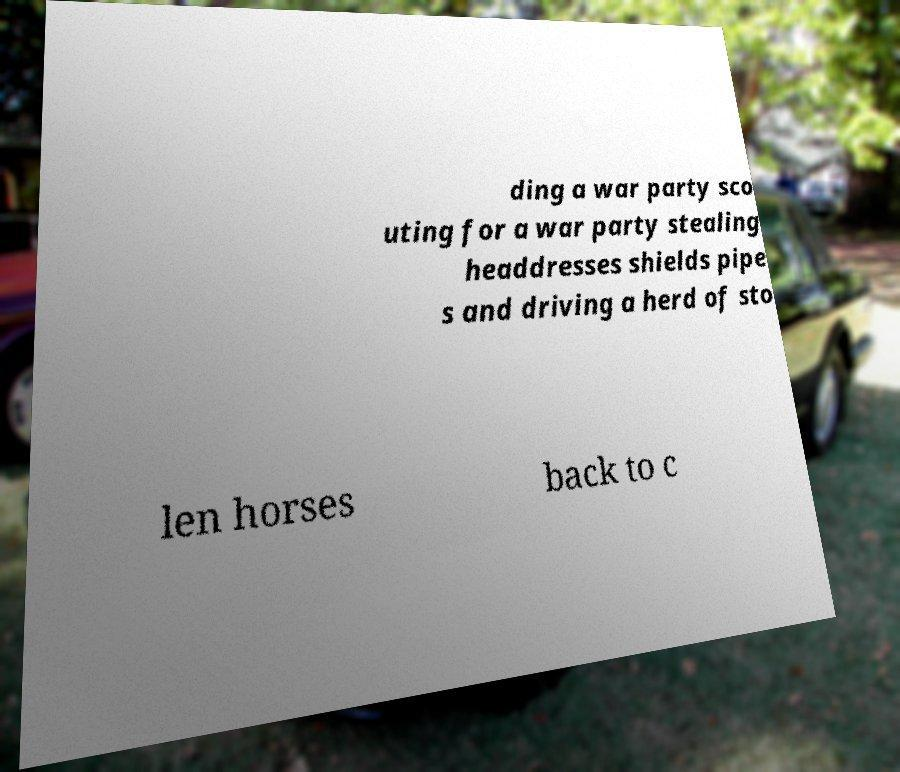Can you read and provide the text displayed in the image?This photo seems to have some interesting text. Can you extract and type it out for me? ding a war party sco uting for a war party stealing headdresses shields pipe s and driving a herd of sto len horses back to c 